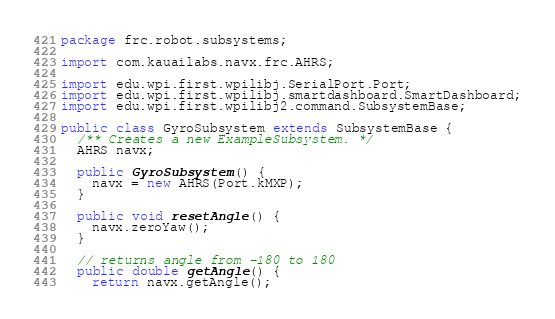<code> <loc_0><loc_0><loc_500><loc_500><_Java_>package frc.robot.subsystems;

import com.kauailabs.navx.frc.AHRS;

import edu.wpi.first.wpilibj.SerialPort.Port;
import edu.wpi.first.wpilibj.smartdashboard.SmartDashboard;
import edu.wpi.first.wpilibj2.command.SubsystemBase;

public class GyroSubsystem extends SubsystemBase {
  /** Creates a new ExampleSubsystem. */
  AHRS navx;

  public GyroSubsystem() {
    navx = new AHRS(Port.kMXP);
  }

  public void resetAngle() {
    navx.zeroYaw();
  }

  // returns angle from -180 to 180
  public double getAngle() {
    return navx.getAngle();</code> 